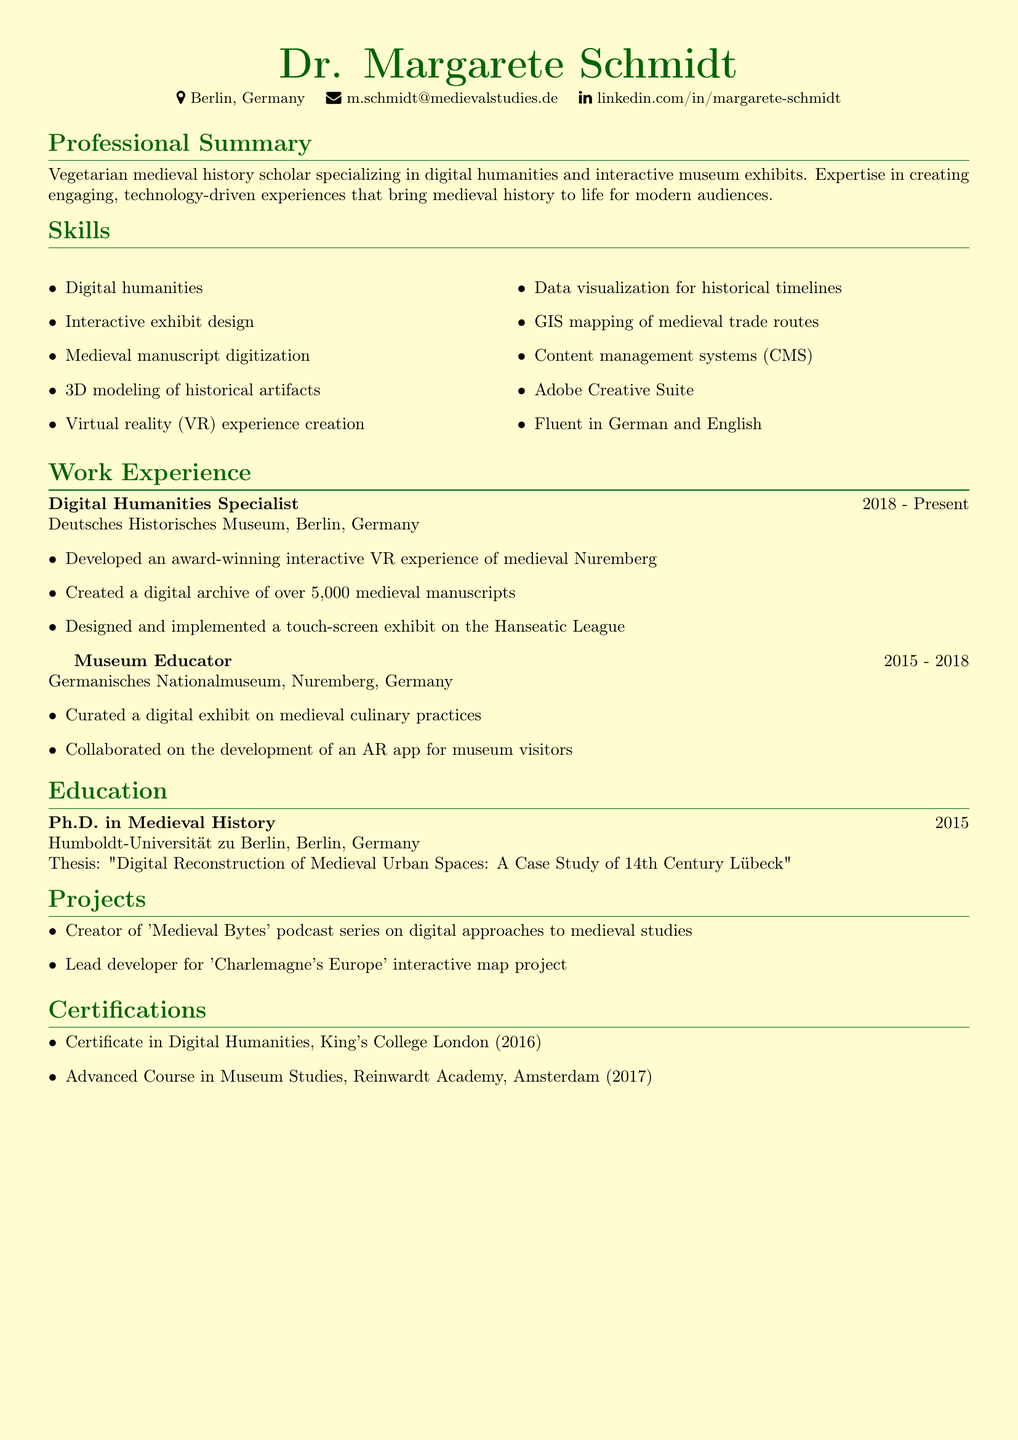What is the name of the scholar? The name of the scholar is provided in the personal information section of the document.
Answer: Dr. Margarete Schmidt What is the location of the Deutsches Historisches Museum? The document states the location of the Deutsches Historisches Museum in the work experience section.
Answer: Berlin, Germany In what year did Dr. Margarete Schmidt complete her Ph.D.? The graduation year for the Ph.D. is listed under the education section of the document.
Answer: 2015 What project involved medieval culinary practices? The document lists specific projects and achievements under the work experience section related to culinary practices.
Answer: Curated a digital exhibit on medieval culinary practices How many years did Dr. Margarete Schmidt work as a Museum Educator? By analyzing the dates in the work experience section, we can calculate the total years worked as a Museum Educator.
Answer: 3 years Which certifying institution awarded the Digital Humanities Certificate? The certification details in the document include the institution that awarded the certificate.
Answer: King's College London What is the title of Dr. Margarete Schmidt's thesis? The thesis title is mentioned in the education section of the document.
Answer: Digital Reconstruction of Medieval Urban Spaces: A Case Study of 14th Century Lübeck What type of exhibits does Dr. Margarete Schmidt specialize in? The professional summary specifically highlights the types of exhibits she specializes in.
Answer: Interactive museum exhibits What digital approach does the podcast 'Medieval Bytes' focus on? The project section mentions the focus of the podcast series created by Dr. Margarete Schmidt.
Answer: Digital approaches to medieval studies 